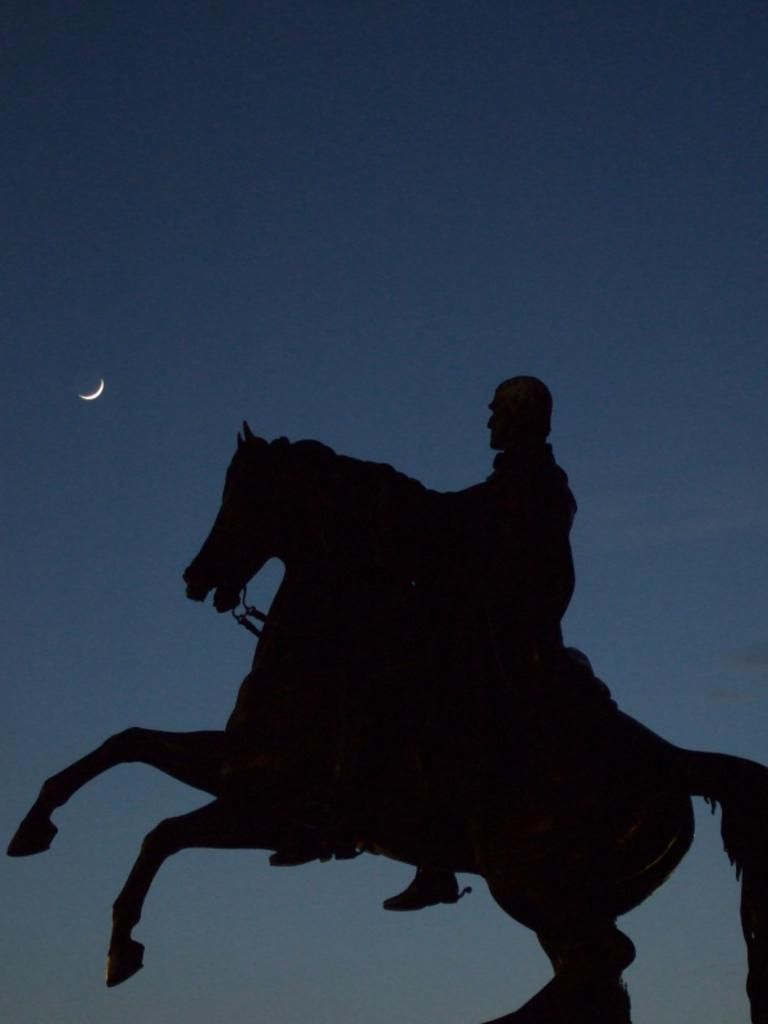What time of day was the image taken? The image was taken during night time. What is happening in the foreground of the image? There is a person riding a horse in the foreground of the image. What celestial body can be seen on the left side of the image? The moon is visible in the sky on the left side of the image. How would you describe the sky in the image? The sky is clear in the image. What type of transport is the kitten using to travel in the image? There is no kitten present in the image, so it cannot be determined what type of transport it might be using. How is the division between the sky and the ground represented in the image? The image does not show a clear division between the sky and the ground; it is a continuous scene. 